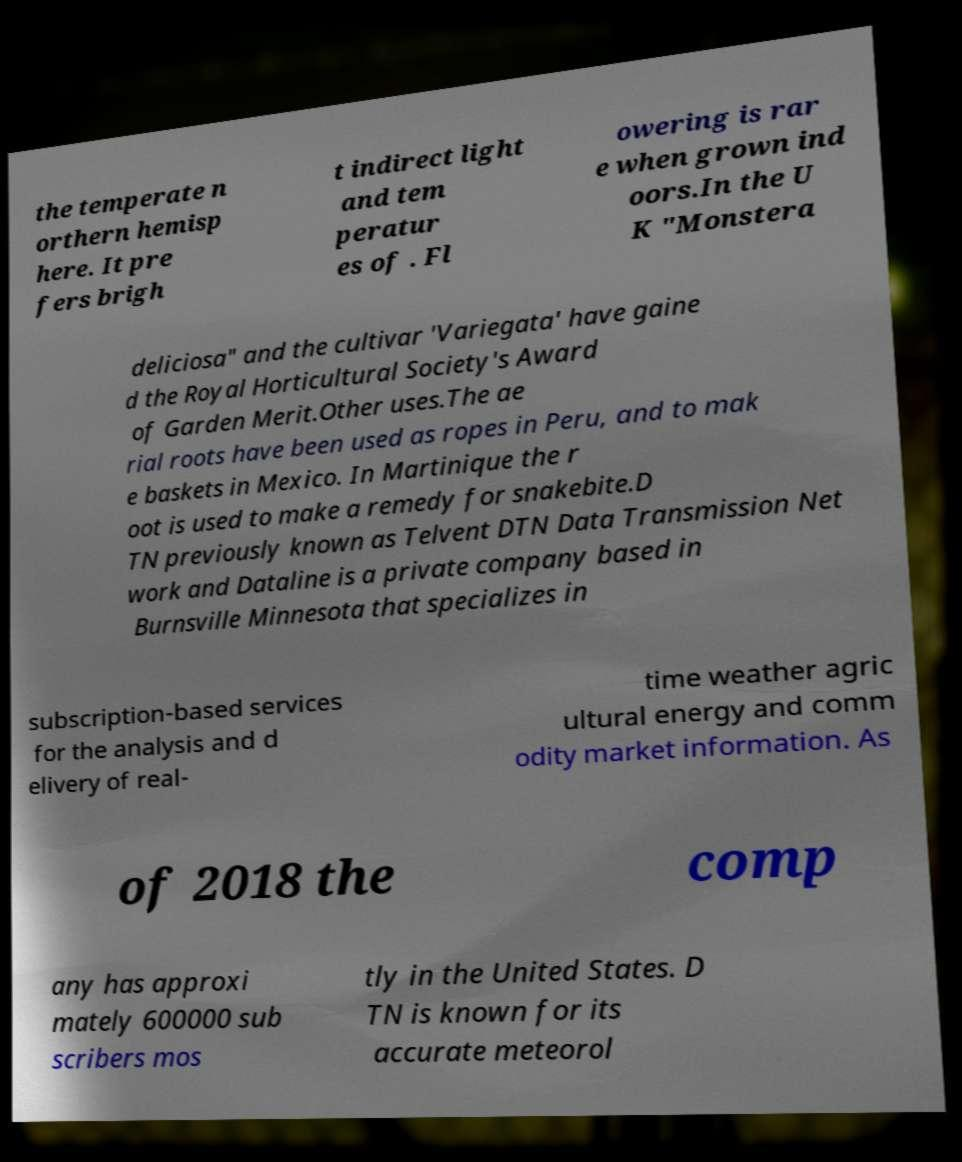There's text embedded in this image that I need extracted. Can you transcribe it verbatim? the temperate n orthern hemisp here. It pre fers brigh t indirect light and tem peratur es of . Fl owering is rar e when grown ind oors.In the U K "Monstera deliciosa" and the cultivar 'Variegata' have gaine d the Royal Horticultural Society's Award of Garden Merit.Other uses.The ae rial roots have been used as ropes in Peru, and to mak e baskets in Mexico. In Martinique the r oot is used to make a remedy for snakebite.D TN previously known as Telvent DTN Data Transmission Net work and Dataline is a private company based in Burnsville Minnesota that specializes in subscription-based services for the analysis and d elivery of real- time weather agric ultural energy and comm odity market information. As of 2018 the comp any has approxi mately 600000 sub scribers mos tly in the United States. D TN is known for its accurate meteorol 